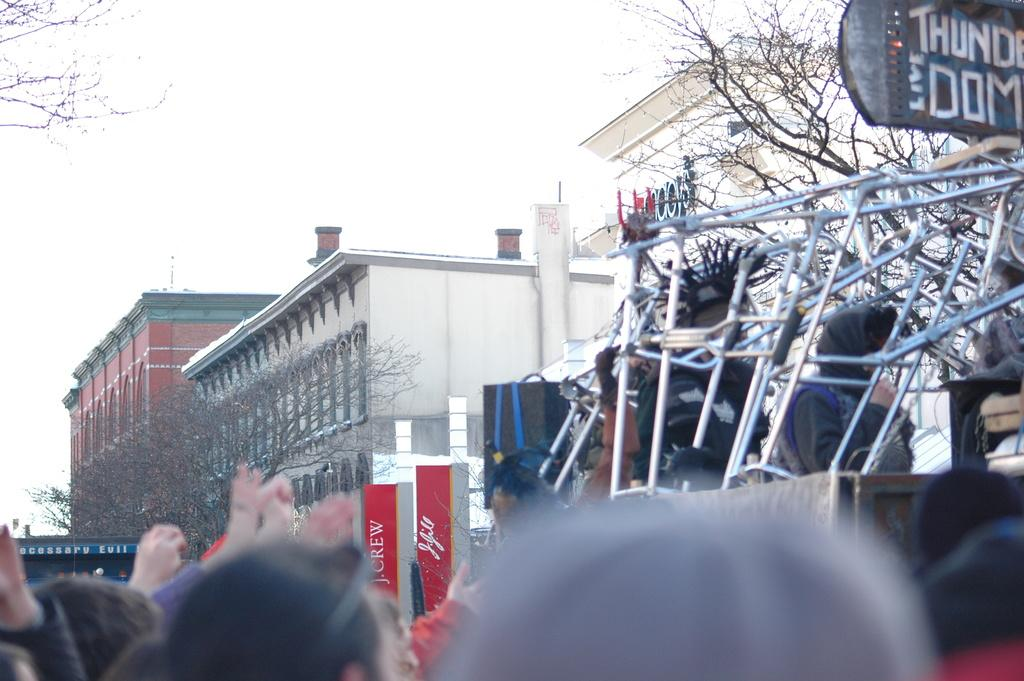How many people are in the image? There is a group of people in the image. What objects can be seen in the image besides the people? There are rods, buildings, trees, name boards, and banners in the image. What is visible in the background of the image? The sky is visible in the background of the image. What type of ring can be seen on the finger of the person in the image? There is no ring visible on any person's finger in the image. What dish is the person in the image cooking? There is no person cooking in the image. What type of fruit is hanging from the trees in the image? There is no fruit visible on the trees in the image. 